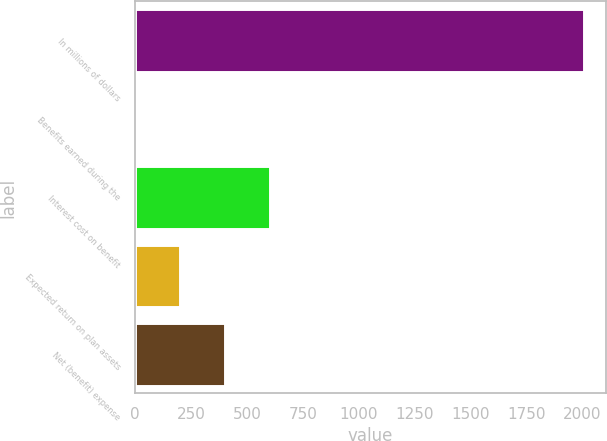Convert chart to OTSL. <chart><loc_0><loc_0><loc_500><loc_500><bar_chart><fcel>In millions of dollars<fcel>Benefits earned during the<fcel>Interest cost on benefit<fcel>Expected return on plan assets<fcel>Net (benefit) expense<nl><fcel>2007<fcel>1<fcel>602.8<fcel>201.6<fcel>402.2<nl></chart> 